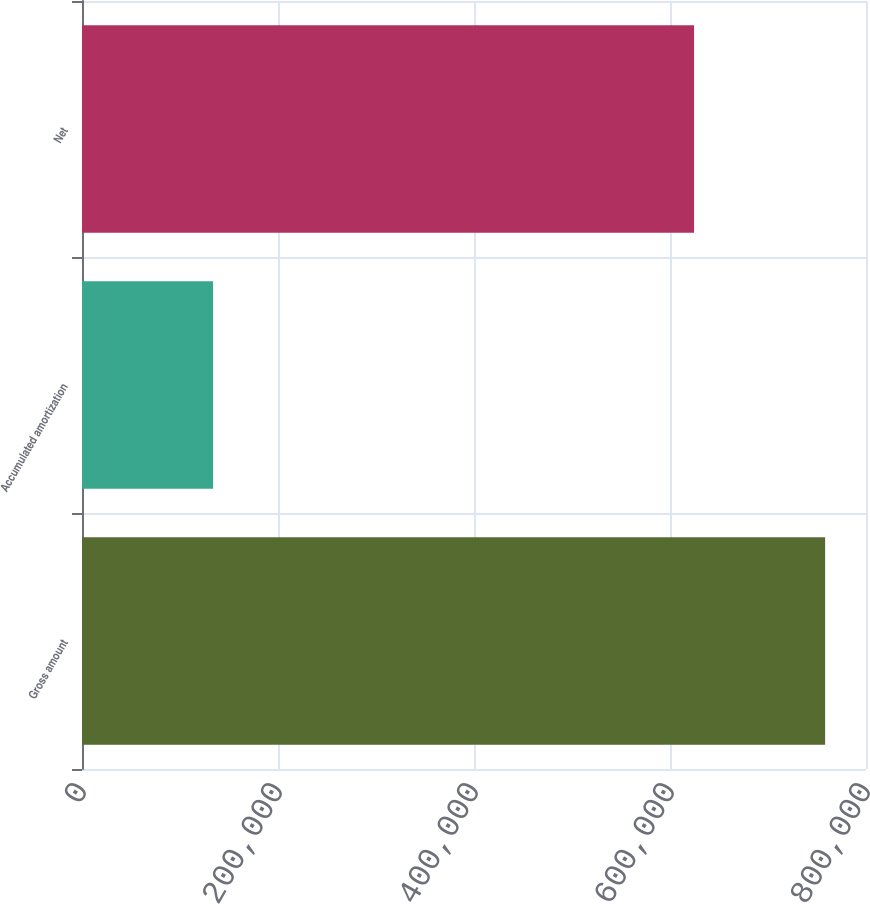<chart> <loc_0><loc_0><loc_500><loc_500><bar_chart><fcel>Gross amount<fcel>Accumulated amortization<fcel>Net<nl><fcel>758300<fcel>133737<fcel>624563<nl></chart> 